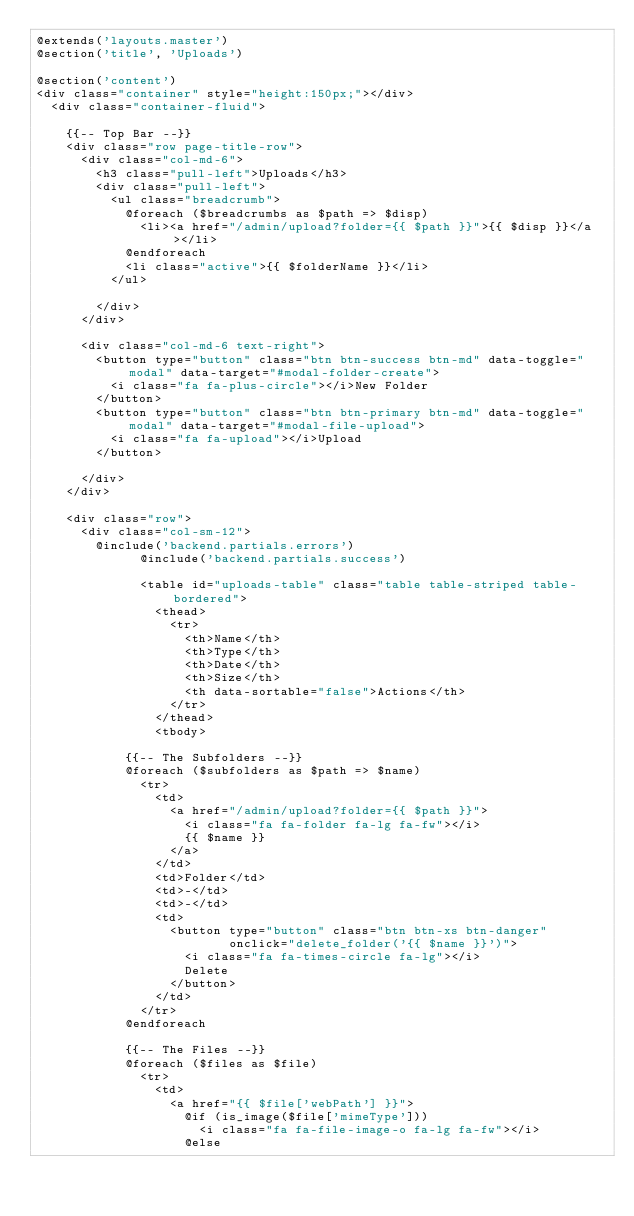Convert code to text. <code><loc_0><loc_0><loc_500><loc_500><_PHP_>@extends('layouts.master')
@section('title', 'Uploads')

@section('content')
<div class="container" style="height:150px;"></div>
	<div class="container-fluid">

		{{-- Top Bar --}}
		<div class="row page-title-row">
			<div class="col-md-6">
				<h3 class="pull-left">Uploads</h3>
				<div class="pull-left">
					<ul class="breadcrumb">
						@foreach ($breadcrumbs as $path => $disp)
							<li><a href="/admin/upload?folder={{ $path }}">{{ $disp }}</a></li>
						@endforeach
						<li class="active">{{ $folderName }}</li>
					</ul>

				</div>
			</div>

			<div class="col-md-6 text-right">
				<button type="button" class="btn btn-success btn-md" data-toggle="modal" data-target="#modal-folder-create">
					<i class="fa fa-plus-circle"></i>New Folder
				</button>
				<button type="button" class="btn btn-primary btn-md" data-toggle="modal" data-target="#modal-file-upload">
					<i class="fa fa-upload"></i>Upload
				</button>
				
			</div>
		</div>

		<div class="row">
			<div class="col-sm-12">
				@include('backend.partials.errors')
            	@include('backend.partials.success')

			        <table id="uploads-table" class="table table-striped table-bordered">
			          <thead>
			            <tr>
			              <th>Name</th>
			              <th>Type</th>
			              <th>Date</th>
			              <th>Size</th>
			              <th data-sortable="false">Actions</th>
			            </tr>
			          </thead>
			          <tbody>

						{{-- The Subfolders --}}
						@foreach ($subfolders as $path => $name)
						  <tr>
						    <td>
						      <a href="/admin/upload?folder={{ $path }}">
						        <i class="fa fa-folder fa-lg fa-fw"></i>
						        {{ $name }}
						      </a>
						    </td>
						    <td>Folder</td>
						    <td>-</td>
						    <td>-</td>
						    <td>
						      <button type="button" class="btn btn-xs btn-danger"
						              onclick="delete_folder('{{ $name }}')">
						        <i class="fa fa-times-circle fa-lg"></i>
						        Delete
						      </button>
						    </td>
						  </tr>
						@endforeach

						{{-- The Files --}}
						@foreach ($files as $file)
						  <tr>
						    <td>
						      <a href="{{ $file['webPath'] }}">
						        @if (is_image($file['mimeType']))
						          <i class="fa fa-file-image-o fa-lg fa-fw"></i>
						        @else</code> 